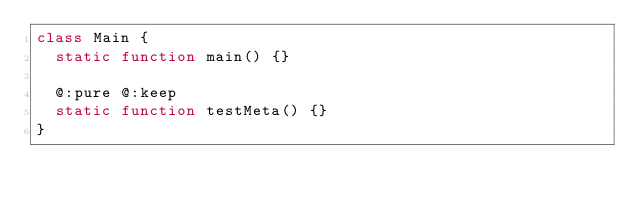Convert code to text. <code><loc_0><loc_0><loc_500><loc_500><_Haxe_>class Main {
	static function main() {}

	@:pure @:keep
	static function testMeta() {}
}</code> 